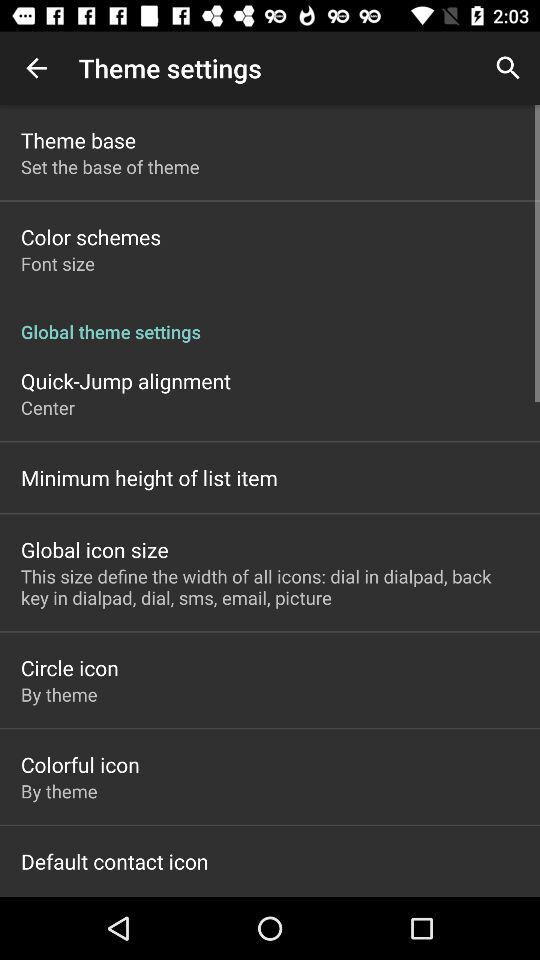What are the options in the "Global theme settings"? The options in the "Global theme settings" are "Quick-Jump alignment", "Minimum height of list item", "Global icon size", "Circle icon", "Colorful icon" and "Default contact icon". 